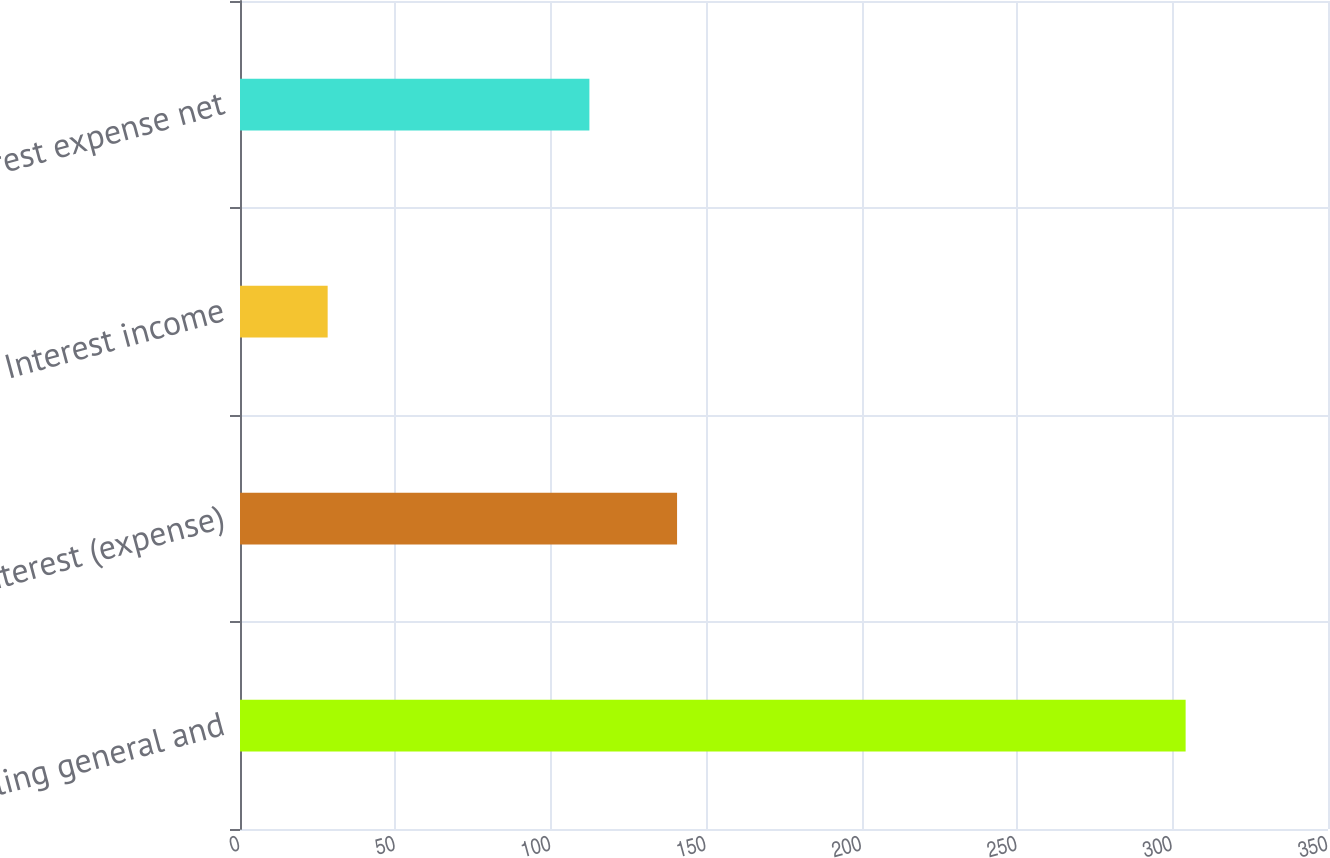<chart> <loc_0><loc_0><loc_500><loc_500><bar_chart><fcel>Selling general and<fcel>Interest (expense)<fcel>Interest income<fcel>Interest expense net<nl><fcel>304.2<fcel>140.6<fcel>28.2<fcel>112.4<nl></chart> 